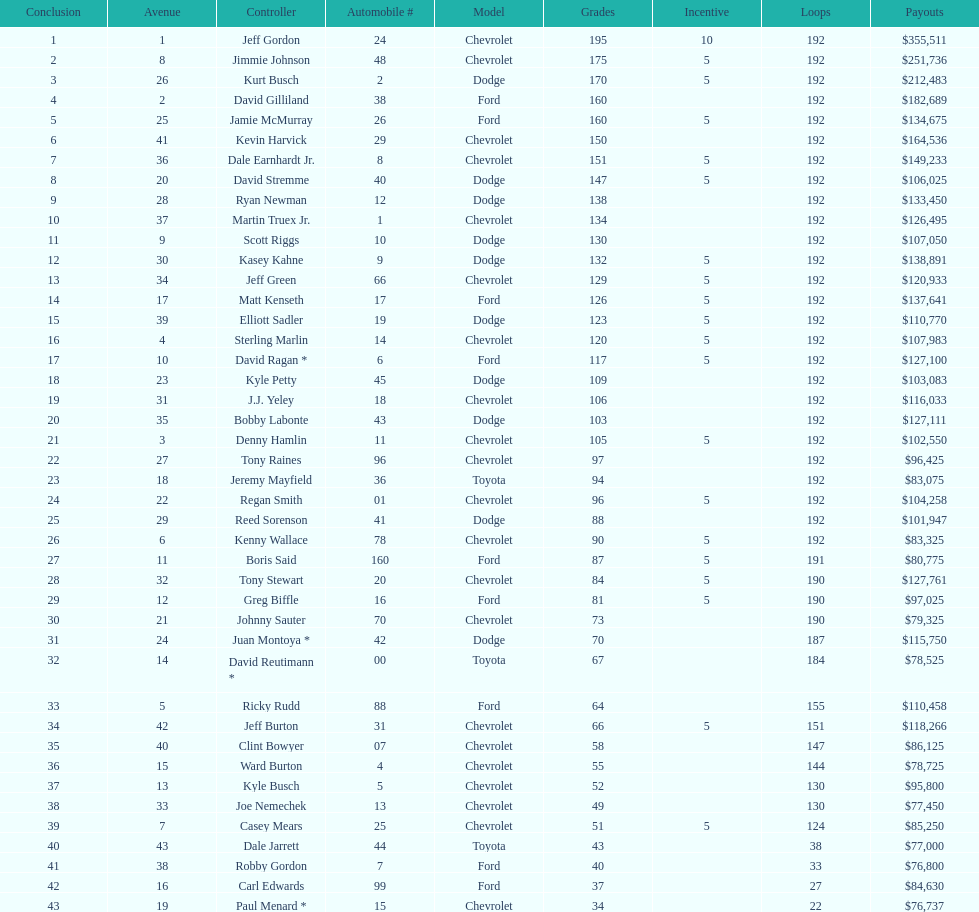How many drivers earned no bonus for this race? 23. 